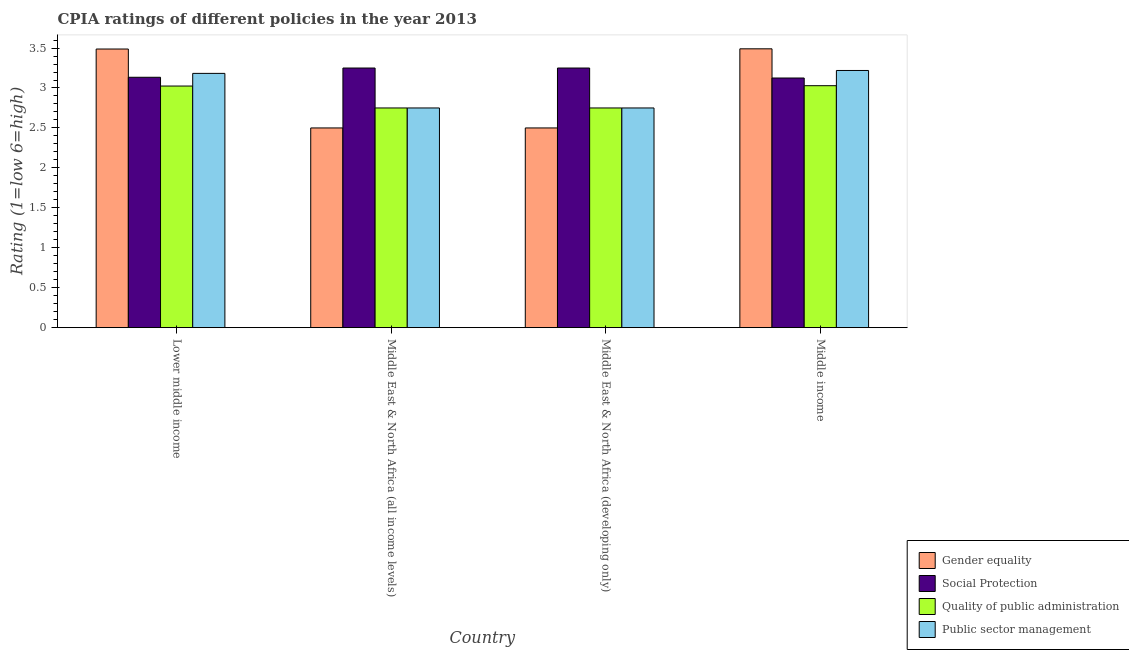How many different coloured bars are there?
Offer a terse response. 4. Are the number of bars per tick equal to the number of legend labels?
Offer a terse response. Yes. Are the number of bars on each tick of the X-axis equal?
Make the answer very short. Yes. How many bars are there on the 2nd tick from the right?
Keep it short and to the point. 4. What is the label of the 4th group of bars from the left?
Provide a short and direct response. Middle income. What is the cpia rating of quality of public administration in Middle East & North Africa (all income levels)?
Your answer should be very brief. 2.75. Across all countries, what is the minimum cpia rating of quality of public administration?
Ensure brevity in your answer.  2.75. In which country was the cpia rating of public sector management minimum?
Make the answer very short. Middle East & North Africa (all income levels). What is the total cpia rating of gender equality in the graph?
Provide a short and direct response. 11.98. What is the difference between the cpia rating of social protection in Lower middle income and that in Middle East & North Africa (all income levels)?
Make the answer very short. -0.12. What is the difference between the cpia rating of social protection in Middle East & North Africa (developing only) and the cpia rating of gender equality in Middle East & North Africa (all income levels)?
Offer a terse response. 0.75. What is the average cpia rating of social protection per country?
Ensure brevity in your answer.  3.19. What is the difference between the cpia rating of public sector management and cpia rating of gender equality in Lower middle income?
Offer a terse response. -0.3. What is the ratio of the cpia rating of gender equality in Middle East & North Africa (all income levels) to that in Middle income?
Make the answer very short. 0.72. Is the cpia rating of gender equality in Middle East & North Africa (developing only) less than that in Middle income?
Ensure brevity in your answer.  Yes. What is the difference between the highest and the second highest cpia rating of gender equality?
Give a very brief answer. 0. What is the difference between the highest and the lowest cpia rating of social protection?
Make the answer very short. 0.12. In how many countries, is the cpia rating of gender equality greater than the average cpia rating of gender equality taken over all countries?
Offer a very short reply. 2. What does the 2nd bar from the left in Middle income represents?
Provide a succinct answer. Social Protection. What does the 1st bar from the right in Lower middle income represents?
Make the answer very short. Public sector management. Are all the bars in the graph horizontal?
Ensure brevity in your answer.  No. How many countries are there in the graph?
Ensure brevity in your answer.  4. Does the graph contain grids?
Your answer should be very brief. No. Where does the legend appear in the graph?
Provide a succinct answer. Bottom right. How many legend labels are there?
Make the answer very short. 4. How are the legend labels stacked?
Make the answer very short. Vertical. What is the title of the graph?
Your answer should be very brief. CPIA ratings of different policies in the year 2013. What is the Rating (1=low 6=high) of Gender equality in Lower middle income?
Make the answer very short. 3.49. What is the Rating (1=low 6=high) in Social Protection in Lower middle income?
Provide a short and direct response. 3.13. What is the Rating (1=low 6=high) in Quality of public administration in Lower middle income?
Offer a terse response. 3.02. What is the Rating (1=low 6=high) of Public sector management in Lower middle income?
Provide a succinct answer. 3.18. What is the Rating (1=low 6=high) of Gender equality in Middle East & North Africa (all income levels)?
Ensure brevity in your answer.  2.5. What is the Rating (1=low 6=high) of Social Protection in Middle East & North Africa (all income levels)?
Ensure brevity in your answer.  3.25. What is the Rating (1=low 6=high) of Quality of public administration in Middle East & North Africa (all income levels)?
Provide a short and direct response. 2.75. What is the Rating (1=low 6=high) of Public sector management in Middle East & North Africa (all income levels)?
Provide a succinct answer. 2.75. What is the Rating (1=low 6=high) of Social Protection in Middle East & North Africa (developing only)?
Offer a very short reply. 3.25. What is the Rating (1=low 6=high) of Quality of public administration in Middle East & North Africa (developing only)?
Your answer should be very brief. 2.75. What is the Rating (1=low 6=high) in Public sector management in Middle East & North Africa (developing only)?
Offer a terse response. 2.75. What is the Rating (1=low 6=high) in Gender equality in Middle income?
Keep it short and to the point. 3.49. What is the Rating (1=low 6=high) in Social Protection in Middle income?
Your response must be concise. 3.12. What is the Rating (1=low 6=high) of Quality of public administration in Middle income?
Ensure brevity in your answer.  3.03. What is the Rating (1=low 6=high) of Public sector management in Middle income?
Make the answer very short. 3.22. Across all countries, what is the maximum Rating (1=low 6=high) in Gender equality?
Your response must be concise. 3.49. Across all countries, what is the maximum Rating (1=low 6=high) of Social Protection?
Make the answer very short. 3.25. Across all countries, what is the maximum Rating (1=low 6=high) of Quality of public administration?
Offer a very short reply. 3.03. Across all countries, what is the maximum Rating (1=low 6=high) of Public sector management?
Ensure brevity in your answer.  3.22. Across all countries, what is the minimum Rating (1=low 6=high) in Gender equality?
Offer a terse response. 2.5. Across all countries, what is the minimum Rating (1=low 6=high) of Social Protection?
Ensure brevity in your answer.  3.12. Across all countries, what is the minimum Rating (1=low 6=high) of Quality of public administration?
Give a very brief answer. 2.75. Across all countries, what is the minimum Rating (1=low 6=high) of Public sector management?
Keep it short and to the point. 2.75. What is the total Rating (1=low 6=high) of Gender equality in the graph?
Your answer should be compact. 11.98. What is the total Rating (1=low 6=high) of Social Protection in the graph?
Offer a terse response. 12.76. What is the total Rating (1=low 6=high) of Quality of public administration in the graph?
Provide a short and direct response. 11.55. What is the total Rating (1=low 6=high) in Public sector management in the graph?
Your answer should be very brief. 11.9. What is the difference between the Rating (1=low 6=high) in Social Protection in Lower middle income and that in Middle East & North Africa (all income levels)?
Your answer should be compact. -0.12. What is the difference between the Rating (1=low 6=high) in Quality of public administration in Lower middle income and that in Middle East & North Africa (all income levels)?
Ensure brevity in your answer.  0.27. What is the difference between the Rating (1=low 6=high) in Public sector management in Lower middle income and that in Middle East & North Africa (all income levels)?
Give a very brief answer. 0.43. What is the difference between the Rating (1=low 6=high) in Social Protection in Lower middle income and that in Middle East & North Africa (developing only)?
Offer a terse response. -0.12. What is the difference between the Rating (1=low 6=high) in Quality of public administration in Lower middle income and that in Middle East & North Africa (developing only)?
Provide a succinct answer. 0.27. What is the difference between the Rating (1=low 6=high) of Public sector management in Lower middle income and that in Middle East & North Africa (developing only)?
Offer a very short reply. 0.43. What is the difference between the Rating (1=low 6=high) of Gender equality in Lower middle income and that in Middle income?
Offer a very short reply. -0. What is the difference between the Rating (1=low 6=high) in Social Protection in Lower middle income and that in Middle income?
Your answer should be very brief. 0.01. What is the difference between the Rating (1=low 6=high) in Quality of public administration in Lower middle income and that in Middle income?
Offer a terse response. -0. What is the difference between the Rating (1=low 6=high) of Public sector management in Lower middle income and that in Middle income?
Your response must be concise. -0.04. What is the difference between the Rating (1=low 6=high) of Gender equality in Middle East & North Africa (all income levels) and that in Middle East & North Africa (developing only)?
Give a very brief answer. 0. What is the difference between the Rating (1=low 6=high) of Quality of public administration in Middle East & North Africa (all income levels) and that in Middle East & North Africa (developing only)?
Ensure brevity in your answer.  0. What is the difference between the Rating (1=low 6=high) in Public sector management in Middle East & North Africa (all income levels) and that in Middle East & North Africa (developing only)?
Keep it short and to the point. 0. What is the difference between the Rating (1=low 6=high) of Gender equality in Middle East & North Africa (all income levels) and that in Middle income?
Offer a terse response. -0.99. What is the difference between the Rating (1=low 6=high) in Social Protection in Middle East & North Africa (all income levels) and that in Middle income?
Provide a succinct answer. 0.12. What is the difference between the Rating (1=low 6=high) in Quality of public administration in Middle East & North Africa (all income levels) and that in Middle income?
Your response must be concise. -0.28. What is the difference between the Rating (1=low 6=high) of Public sector management in Middle East & North Africa (all income levels) and that in Middle income?
Provide a short and direct response. -0.47. What is the difference between the Rating (1=low 6=high) in Gender equality in Middle East & North Africa (developing only) and that in Middle income?
Your response must be concise. -0.99. What is the difference between the Rating (1=low 6=high) in Quality of public administration in Middle East & North Africa (developing only) and that in Middle income?
Provide a succinct answer. -0.28. What is the difference between the Rating (1=low 6=high) of Public sector management in Middle East & North Africa (developing only) and that in Middle income?
Make the answer very short. -0.47. What is the difference between the Rating (1=low 6=high) of Gender equality in Lower middle income and the Rating (1=low 6=high) of Social Protection in Middle East & North Africa (all income levels)?
Offer a terse response. 0.24. What is the difference between the Rating (1=low 6=high) of Gender equality in Lower middle income and the Rating (1=low 6=high) of Quality of public administration in Middle East & North Africa (all income levels)?
Your answer should be compact. 0.74. What is the difference between the Rating (1=low 6=high) in Gender equality in Lower middle income and the Rating (1=low 6=high) in Public sector management in Middle East & North Africa (all income levels)?
Provide a short and direct response. 0.74. What is the difference between the Rating (1=low 6=high) in Social Protection in Lower middle income and the Rating (1=low 6=high) in Quality of public administration in Middle East & North Africa (all income levels)?
Your answer should be compact. 0.38. What is the difference between the Rating (1=low 6=high) in Social Protection in Lower middle income and the Rating (1=low 6=high) in Public sector management in Middle East & North Africa (all income levels)?
Provide a short and direct response. 0.38. What is the difference between the Rating (1=low 6=high) in Quality of public administration in Lower middle income and the Rating (1=low 6=high) in Public sector management in Middle East & North Africa (all income levels)?
Offer a very short reply. 0.27. What is the difference between the Rating (1=low 6=high) in Gender equality in Lower middle income and the Rating (1=low 6=high) in Social Protection in Middle East & North Africa (developing only)?
Make the answer very short. 0.24. What is the difference between the Rating (1=low 6=high) of Gender equality in Lower middle income and the Rating (1=low 6=high) of Quality of public administration in Middle East & North Africa (developing only)?
Your answer should be compact. 0.74. What is the difference between the Rating (1=low 6=high) in Gender equality in Lower middle income and the Rating (1=low 6=high) in Public sector management in Middle East & North Africa (developing only)?
Your answer should be very brief. 0.74. What is the difference between the Rating (1=low 6=high) of Social Protection in Lower middle income and the Rating (1=low 6=high) of Quality of public administration in Middle East & North Africa (developing only)?
Provide a succinct answer. 0.38. What is the difference between the Rating (1=low 6=high) in Social Protection in Lower middle income and the Rating (1=low 6=high) in Public sector management in Middle East & North Africa (developing only)?
Provide a succinct answer. 0.38. What is the difference between the Rating (1=low 6=high) in Quality of public administration in Lower middle income and the Rating (1=low 6=high) in Public sector management in Middle East & North Africa (developing only)?
Give a very brief answer. 0.27. What is the difference between the Rating (1=low 6=high) of Gender equality in Lower middle income and the Rating (1=low 6=high) of Social Protection in Middle income?
Your answer should be very brief. 0.36. What is the difference between the Rating (1=low 6=high) of Gender equality in Lower middle income and the Rating (1=low 6=high) of Quality of public administration in Middle income?
Offer a very short reply. 0.46. What is the difference between the Rating (1=low 6=high) in Gender equality in Lower middle income and the Rating (1=low 6=high) in Public sector management in Middle income?
Offer a terse response. 0.27. What is the difference between the Rating (1=low 6=high) in Social Protection in Lower middle income and the Rating (1=low 6=high) in Quality of public administration in Middle income?
Your answer should be very brief. 0.11. What is the difference between the Rating (1=low 6=high) in Social Protection in Lower middle income and the Rating (1=low 6=high) in Public sector management in Middle income?
Make the answer very short. -0.09. What is the difference between the Rating (1=low 6=high) in Quality of public administration in Lower middle income and the Rating (1=low 6=high) in Public sector management in Middle income?
Your answer should be very brief. -0.19. What is the difference between the Rating (1=low 6=high) of Gender equality in Middle East & North Africa (all income levels) and the Rating (1=low 6=high) of Social Protection in Middle East & North Africa (developing only)?
Offer a very short reply. -0.75. What is the difference between the Rating (1=low 6=high) in Gender equality in Middle East & North Africa (all income levels) and the Rating (1=low 6=high) in Quality of public administration in Middle East & North Africa (developing only)?
Provide a succinct answer. -0.25. What is the difference between the Rating (1=low 6=high) in Social Protection in Middle East & North Africa (all income levels) and the Rating (1=low 6=high) in Quality of public administration in Middle East & North Africa (developing only)?
Make the answer very short. 0.5. What is the difference between the Rating (1=low 6=high) of Social Protection in Middle East & North Africa (all income levels) and the Rating (1=low 6=high) of Public sector management in Middle East & North Africa (developing only)?
Provide a short and direct response. 0.5. What is the difference between the Rating (1=low 6=high) in Gender equality in Middle East & North Africa (all income levels) and the Rating (1=low 6=high) in Social Protection in Middle income?
Your answer should be compact. -0.62. What is the difference between the Rating (1=low 6=high) of Gender equality in Middle East & North Africa (all income levels) and the Rating (1=low 6=high) of Quality of public administration in Middle income?
Make the answer very short. -0.53. What is the difference between the Rating (1=low 6=high) in Gender equality in Middle East & North Africa (all income levels) and the Rating (1=low 6=high) in Public sector management in Middle income?
Your response must be concise. -0.72. What is the difference between the Rating (1=low 6=high) of Social Protection in Middle East & North Africa (all income levels) and the Rating (1=low 6=high) of Quality of public administration in Middle income?
Make the answer very short. 0.22. What is the difference between the Rating (1=low 6=high) in Social Protection in Middle East & North Africa (all income levels) and the Rating (1=low 6=high) in Public sector management in Middle income?
Your response must be concise. 0.03. What is the difference between the Rating (1=low 6=high) in Quality of public administration in Middle East & North Africa (all income levels) and the Rating (1=low 6=high) in Public sector management in Middle income?
Your response must be concise. -0.47. What is the difference between the Rating (1=low 6=high) in Gender equality in Middle East & North Africa (developing only) and the Rating (1=low 6=high) in Social Protection in Middle income?
Provide a short and direct response. -0.62. What is the difference between the Rating (1=low 6=high) of Gender equality in Middle East & North Africa (developing only) and the Rating (1=low 6=high) of Quality of public administration in Middle income?
Keep it short and to the point. -0.53. What is the difference between the Rating (1=low 6=high) in Gender equality in Middle East & North Africa (developing only) and the Rating (1=low 6=high) in Public sector management in Middle income?
Make the answer very short. -0.72. What is the difference between the Rating (1=low 6=high) of Social Protection in Middle East & North Africa (developing only) and the Rating (1=low 6=high) of Quality of public administration in Middle income?
Provide a short and direct response. 0.22. What is the difference between the Rating (1=low 6=high) of Social Protection in Middle East & North Africa (developing only) and the Rating (1=low 6=high) of Public sector management in Middle income?
Your response must be concise. 0.03. What is the difference between the Rating (1=low 6=high) of Quality of public administration in Middle East & North Africa (developing only) and the Rating (1=low 6=high) of Public sector management in Middle income?
Make the answer very short. -0.47. What is the average Rating (1=low 6=high) of Gender equality per country?
Offer a very short reply. 2.99. What is the average Rating (1=low 6=high) of Social Protection per country?
Provide a short and direct response. 3.19. What is the average Rating (1=low 6=high) in Quality of public administration per country?
Your response must be concise. 2.89. What is the average Rating (1=low 6=high) in Public sector management per country?
Your answer should be compact. 2.98. What is the difference between the Rating (1=low 6=high) of Gender equality and Rating (1=low 6=high) of Social Protection in Lower middle income?
Provide a succinct answer. 0.35. What is the difference between the Rating (1=low 6=high) in Gender equality and Rating (1=low 6=high) in Quality of public administration in Lower middle income?
Provide a short and direct response. 0.46. What is the difference between the Rating (1=low 6=high) in Gender equality and Rating (1=low 6=high) in Public sector management in Lower middle income?
Offer a very short reply. 0.3. What is the difference between the Rating (1=low 6=high) in Social Protection and Rating (1=low 6=high) in Quality of public administration in Lower middle income?
Give a very brief answer. 0.11. What is the difference between the Rating (1=low 6=high) in Social Protection and Rating (1=low 6=high) in Public sector management in Lower middle income?
Your response must be concise. -0.05. What is the difference between the Rating (1=low 6=high) of Quality of public administration and Rating (1=low 6=high) of Public sector management in Lower middle income?
Keep it short and to the point. -0.16. What is the difference between the Rating (1=low 6=high) of Gender equality and Rating (1=low 6=high) of Social Protection in Middle East & North Africa (all income levels)?
Keep it short and to the point. -0.75. What is the difference between the Rating (1=low 6=high) in Gender equality and Rating (1=low 6=high) in Quality of public administration in Middle East & North Africa (all income levels)?
Provide a short and direct response. -0.25. What is the difference between the Rating (1=low 6=high) in Social Protection and Rating (1=low 6=high) in Public sector management in Middle East & North Africa (all income levels)?
Provide a succinct answer. 0.5. What is the difference between the Rating (1=low 6=high) in Quality of public administration and Rating (1=low 6=high) in Public sector management in Middle East & North Africa (all income levels)?
Make the answer very short. 0. What is the difference between the Rating (1=low 6=high) of Gender equality and Rating (1=low 6=high) of Social Protection in Middle East & North Africa (developing only)?
Ensure brevity in your answer.  -0.75. What is the difference between the Rating (1=low 6=high) of Quality of public administration and Rating (1=low 6=high) of Public sector management in Middle East & North Africa (developing only)?
Offer a very short reply. 0. What is the difference between the Rating (1=low 6=high) in Gender equality and Rating (1=low 6=high) in Social Protection in Middle income?
Provide a short and direct response. 0.37. What is the difference between the Rating (1=low 6=high) of Gender equality and Rating (1=low 6=high) of Quality of public administration in Middle income?
Offer a terse response. 0.46. What is the difference between the Rating (1=low 6=high) of Gender equality and Rating (1=low 6=high) of Public sector management in Middle income?
Give a very brief answer. 0.27. What is the difference between the Rating (1=low 6=high) of Social Protection and Rating (1=low 6=high) of Quality of public administration in Middle income?
Your answer should be very brief. 0.1. What is the difference between the Rating (1=low 6=high) in Social Protection and Rating (1=low 6=high) in Public sector management in Middle income?
Offer a very short reply. -0.09. What is the difference between the Rating (1=low 6=high) in Quality of public administration and Rating (1=low 6=high) in Public sector management in Middle income?
Provide a succinct answer. -0.19. What is the ratio of the Rating (1=low 6=high) in Gender equality in Lower middle income to that in Middle East & North Africa (all income levels)?
Your answer should be very brief. 1.4. What is the ratio of the Rating (1=low 6=high) in Social Protection in Lower middle income to that in Middle East & North Africa (all income levels)?
Offer a very short reply. 0.96. What is the ratio of the Rating (1=low 6=high) of Quality of public administration in Lower middle income to that in Middle East & North Africa (all income levels)?
Offer a very short reply. 1.1. What is the ratio of the Rating (1=low 6=high) of Public sector management in Lower middle income to that in Middle East & North Africa (all income levels)?
Your answer should be very brief. 1.16. What is the ratio of the Rating (1=low 6=high) in Gender equality in Lower middle income to that in Middle East & North Africa (developing only)?
Keep it short and to the point. 1.4. What is the ratio of the Rating (1=low 6=high) in Social Protection in Lower middle income to that in Middle East & North Africa (developing only)?
Keep it short and to the point. 0.96. What is the ratio of the Rating (1=low 6=high) of Quality of public administration in Lower middle income to that in Middle East & North Africa (developing only)?
Ensure brevity in your answer.  1.1. What is the ratio of the Rating (1=low 6=high) in Public sector management in Lower middle income to that in Middle East & North Africa (developing only)?
Your answer should be very brief. 1.16. What is the ratio of the Rating (1=low 6=high) of Gender equality in Lower middle income to that in Middle income?
Your response must be concise. 1. What is the ratio of the Rating (1=low 6=high) of Public sector management in Lower middle income to that in Middle income?
Ensure brevity in your answer.  0.99. What is the ratio of the Rating (1=low 6=high) of Gender equality in Middle East & North Africa (all income levels) to that in Middle East & North Africa (developing only)?
Give a very brief answer. 1. What is the ratio of the Rating (1=low 6=high) in Quality of public administration in Middle East & North Africa (all income levels) to that in Middle East & North Africa (developing only)?
Offer a very short reply. 1. What is the ratio of the Rating (1=low 6=high) of Public sector management in Middle East & North Africa (all income levels) to that in Middle East & North Africa (developing only)?
Offer a very short reply. 1. What is the ratio of the Rating (1=low 6=high) of Gender equality in Middle East & North Africa (all income levels) to that in Middle income?
Provide a succinct answer. 0.72. What is the ratio of the Rating (1=low 6=high) in Social Protection in Middle East & North Africa (all income levels) to that in Middle income?
Provide a short and direct response. 1.04. What is the ratio of the Rating (1=low 6=high) in Quality of public administration in Middle East & North Africa (all income levels) to that in Middle income?
Provide a short and direct response. 0.91. What is the ratio of the Rating (1=low 6=high) in Public sector management in Middle East & North Africa (all income levels) to that in Middle income?
Ensure brevity in your answer.  0.85. What is the ratio of the Rating (1=low 6=high) of Gender equality in Middle East & North Africa (developing only) to that in Middle income?
Keep it short and to the point. 0.72. What is the ratio of the Rating (1=low 6=high) of Quality of public administration in Middle East & North Africa (developing only) to that in Middle income?
Your response must be concise. 0.91. What is the ratio of the Rating (1=low 6=high) of Public sector management in Middle East & North Africa (developing only) to that in Middle income?
Your response must be concise. 0.85. What is the difference between the highest and the second highest Rating (1=low 6=high) in Gender equality?
Offer a very short reply. 0. What is the difference between the highest and the second highest Rating (1=low 6=high) in Quality of public administration?
Make the answer very short. 0. What is the difference between the highest and the second highest Rating (1=low 6=high) in Public sector management?
Your response must be concise. 0.04. What is the difference between the highest and the lowest Rating (1=low 6=high) in Gender equality?
Ensure brevity in your answer.  0.99. What is the difference between the highest and the lowest Rating (1=low 6=high) of Quality of public administration?
Your answer should be very brief. 0.28. What is the difference between the highest and the lowest Rating (1=low 6=high) in Public sector management?
Provide a short and direct response. 0.47. 